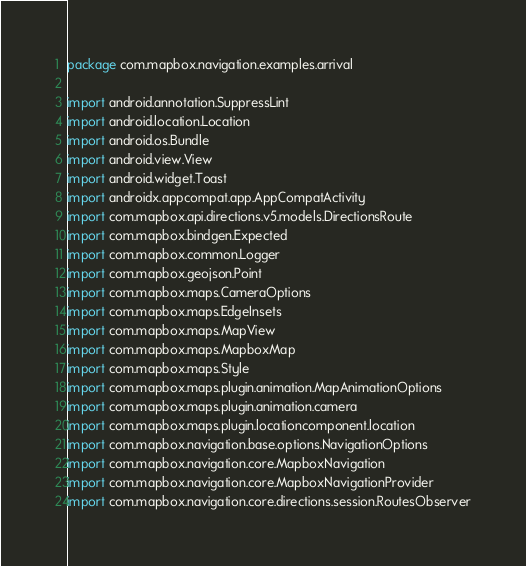Convert code to text. <code><loc_0><loc_0><loc_500><loc_500><_Kotlin_>package com.mapbox.navigation.examples.arrival

import android.annotation.SuppressLint
import android.location.Location
import android.os.Bundle
import android.view.View
import android.widget.Toast
import androidx.appcompat.app.AppCompatActivity
import com.mapbox.api.directions.v5.models.DirectionsRoute
import com.mapbox.bindgen.Expected
import com.mapbox.common.Logger
import com.mapbox.geojson.Point
import com.mapbox.maps.CameraOptions
import com.mapbox.maps.EdgeInsets
import com.mapbox.maps.MapView
import com.mapbox.maps.MapboxMap
import com.mapbox.maps.Style
import com.mapbox.maps.plugin.animation.MapAnimationOptions
import com.mapbox.maps.plugin.animation.camera
import com.mapbox.maps.plugin.locationcomponent.location
import com.mapbox.navigation.base.options.NavigationOptions
import com.mapbox.navigation.core.MapboxNavigation
import com.mapbox.navigation.core.MapboxNavigationProvider
import com.mapbox.navigation.core.directions.session.RoutesObserver</code> 